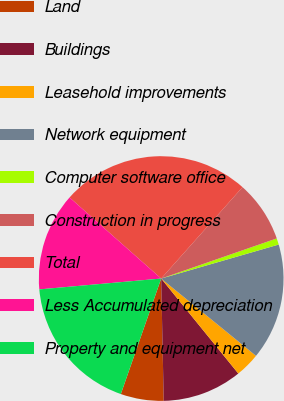Convert chart to OTSL. <chart><loc_0><loc_0><loc_500><loc_500><pie_chart><fcel>Land<fcel>Buildings<fcel>Leasehold improvements<fcel>Network equipment<fcel>Computer software office<fcel>Construction in progress<fcel>Total<fcel>Less Accumulated depreciation<fcel>Property and equipment net<nl><fcel>5.68%<fcel>10.52%<fcel>3.26%<fcel>15.36%<fcel>0.84%<fcel>8.1%<fcel>25.04%<fcel>12.94%<fcel>18.23%<nl></chart> 